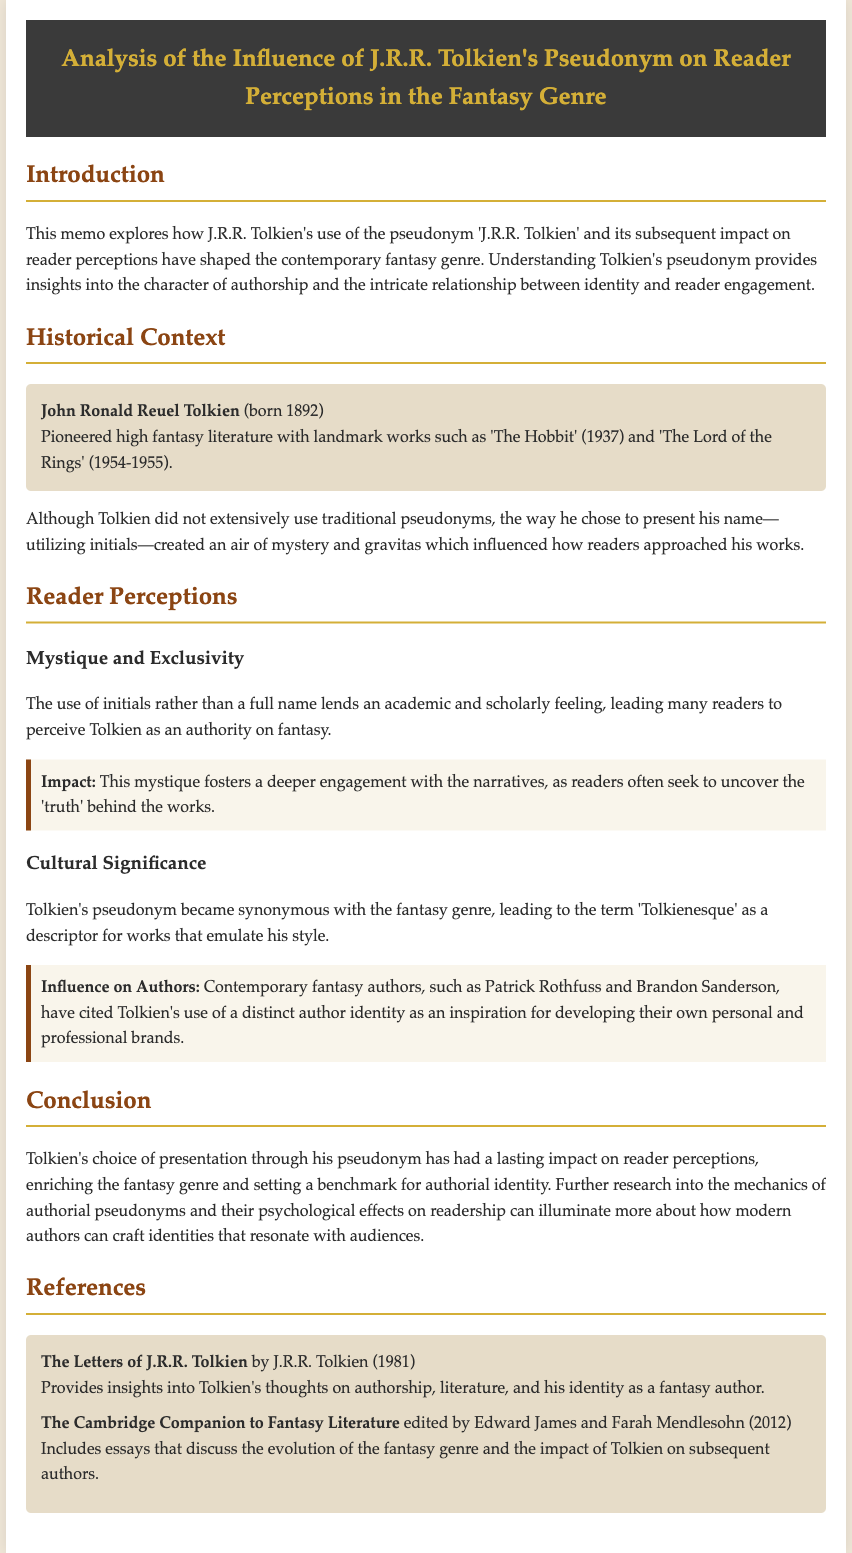What is J.R.R. Tolkien's full name? The document states that J.R.R. Tolkien's full name is John Ronald Reuel Tolkien.
Answer: John Ronald Reuel Tolkien In what year was 'The Hobbit' published? According to the document, 'The Hobbit' was published in 1937.
Answer: 1937 What term describes works that emulate Tolkien's style? The document mentions the term 'Tolkienesque' as a descriptor for such works.
Answer: Tolkienesque What has Tolkien's pseudonym fostered in terms of reader engagement? The memo states that Tolkien's pseudonym fosters a deeper engagement with the narratives.
Answer: Deeper engagement Who are two contemporary authors inspired by Tolkien's distinct author identity? The document mentions Patrick Rothfuss and Brandon Sanderson as authors influenced by Tolkien.
Answer: Patrick Rothfuss and Brandon Sanderson What is the publication year of "The Letters of J.R.R. Tolkien"? The memo indicates that "The Letters of J.R.R. Tolkien" was published in 1981.
Answer: 1981 What aspect of Tolkien's pseudonym contributed to the air of mystery? The document explains that his use of initials instead of a full name contributed to the mystique.
Answer: Use of initials What type of memoir is being analyzed in this document? The document is an analysis memo exploring Tolkien's pseudonym influence.
Answer: Memo What is one psychological effect of authorial pseudonyms mentioned? The document suggests exploring how these pseudonyms can illuminate modern authors' identity crafting.
Answer: Identity crafting 